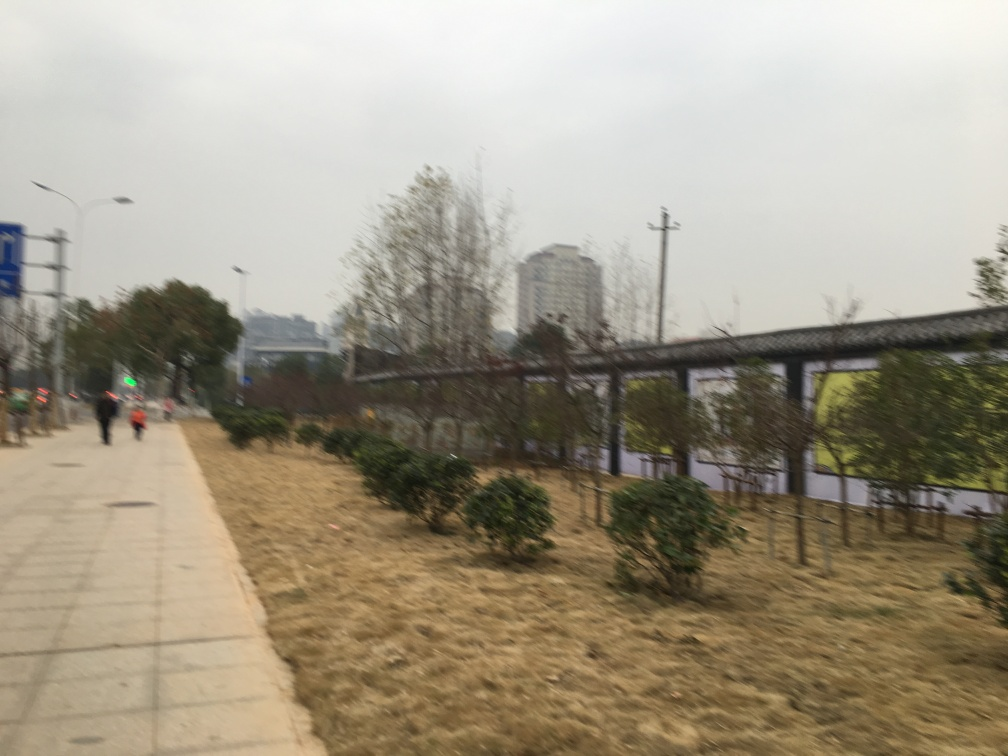What details can you provide about the urban environment captured in this photograph? The photo shows a paved pathway that appears to be part of an urban park or a side road. Buildings in the distance indicate the proximity to a developed area. The presence of street lamps and traffic signage also point to an urban setting, while the attempted cultivation of plant life along the path reflects an effort to integrate greenery within the cityscape. 